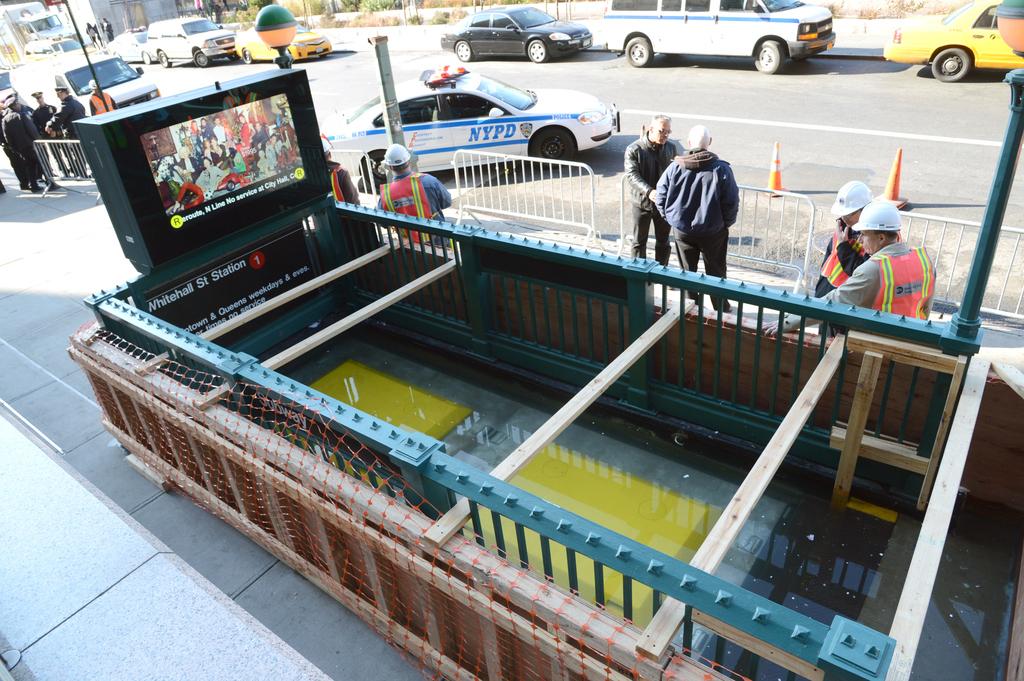What does it say on the police car?
Give a very brief answer. Nypd. 